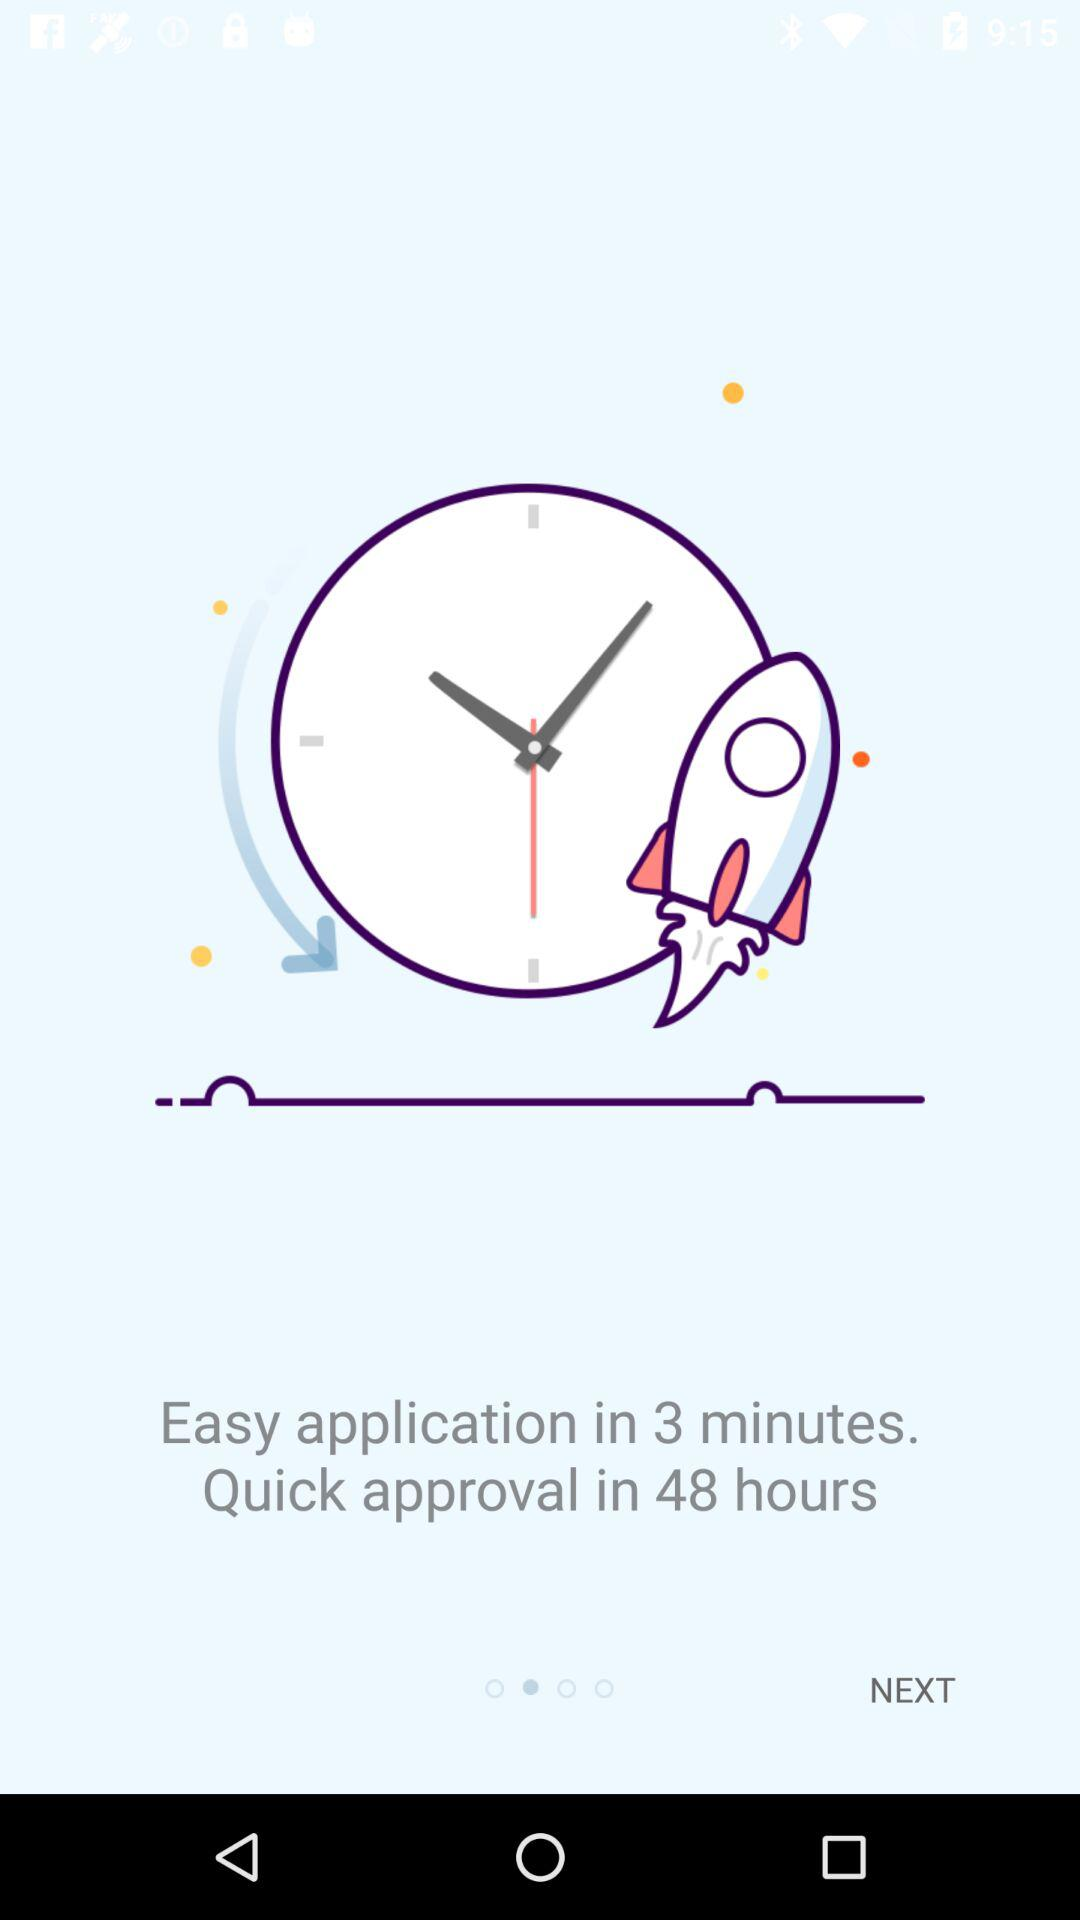What is the time duration of the quick approval? The time duration of the quick approval is 48 hours. 